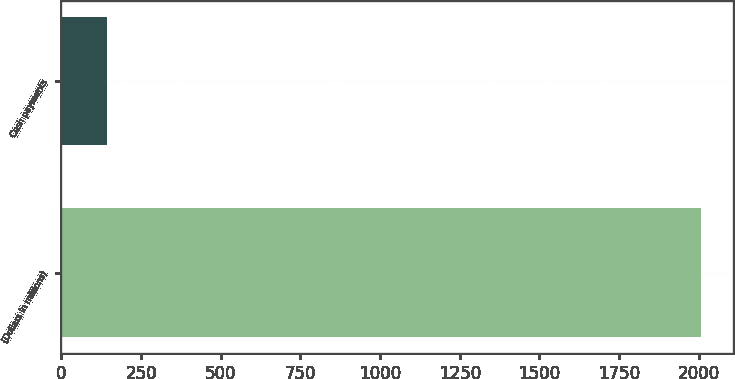Convert chart to OTSL. <chart><loc_0><loc_0><loc_500><loc_500><bar_chart><fcel>(Dollars in millions)<fcel>Cash payments<nl><fcel>2006<fcel>144<nl></chart> 